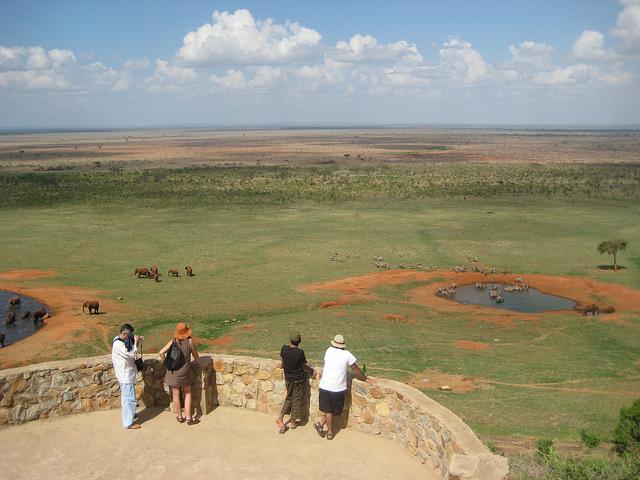What is white?
Give a very brief answer. Shirt. How many people are standing at the wall?
Write a very short answer. 4. See any trees?
Concise answer only. Yes. Is the wall made of stones?
Be succinct. Yes. Are there any animals in the picture?
Give a very brief answer. Yes. 